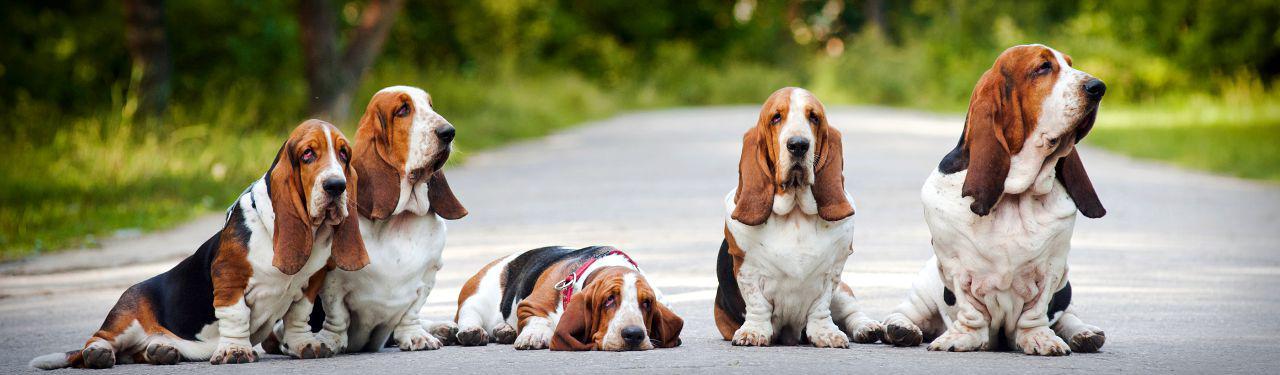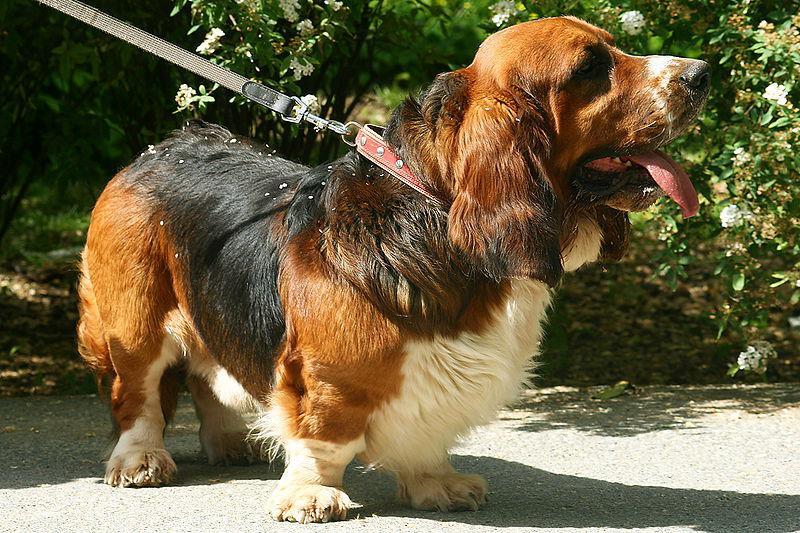The first image is the image on the left, the second image is the image on the right. Assess this claim about the two images: "In total, we have more than two dogs here.". Correct or not? Answer yes or no. Yes. The first image is the image on the left, the second image is the image on the right. For the images displayed, is the sentence "One of the image shows a single dog on a leash and the other shows a group of at least three dogs." factually correct? Answer yes or no. Yes. 